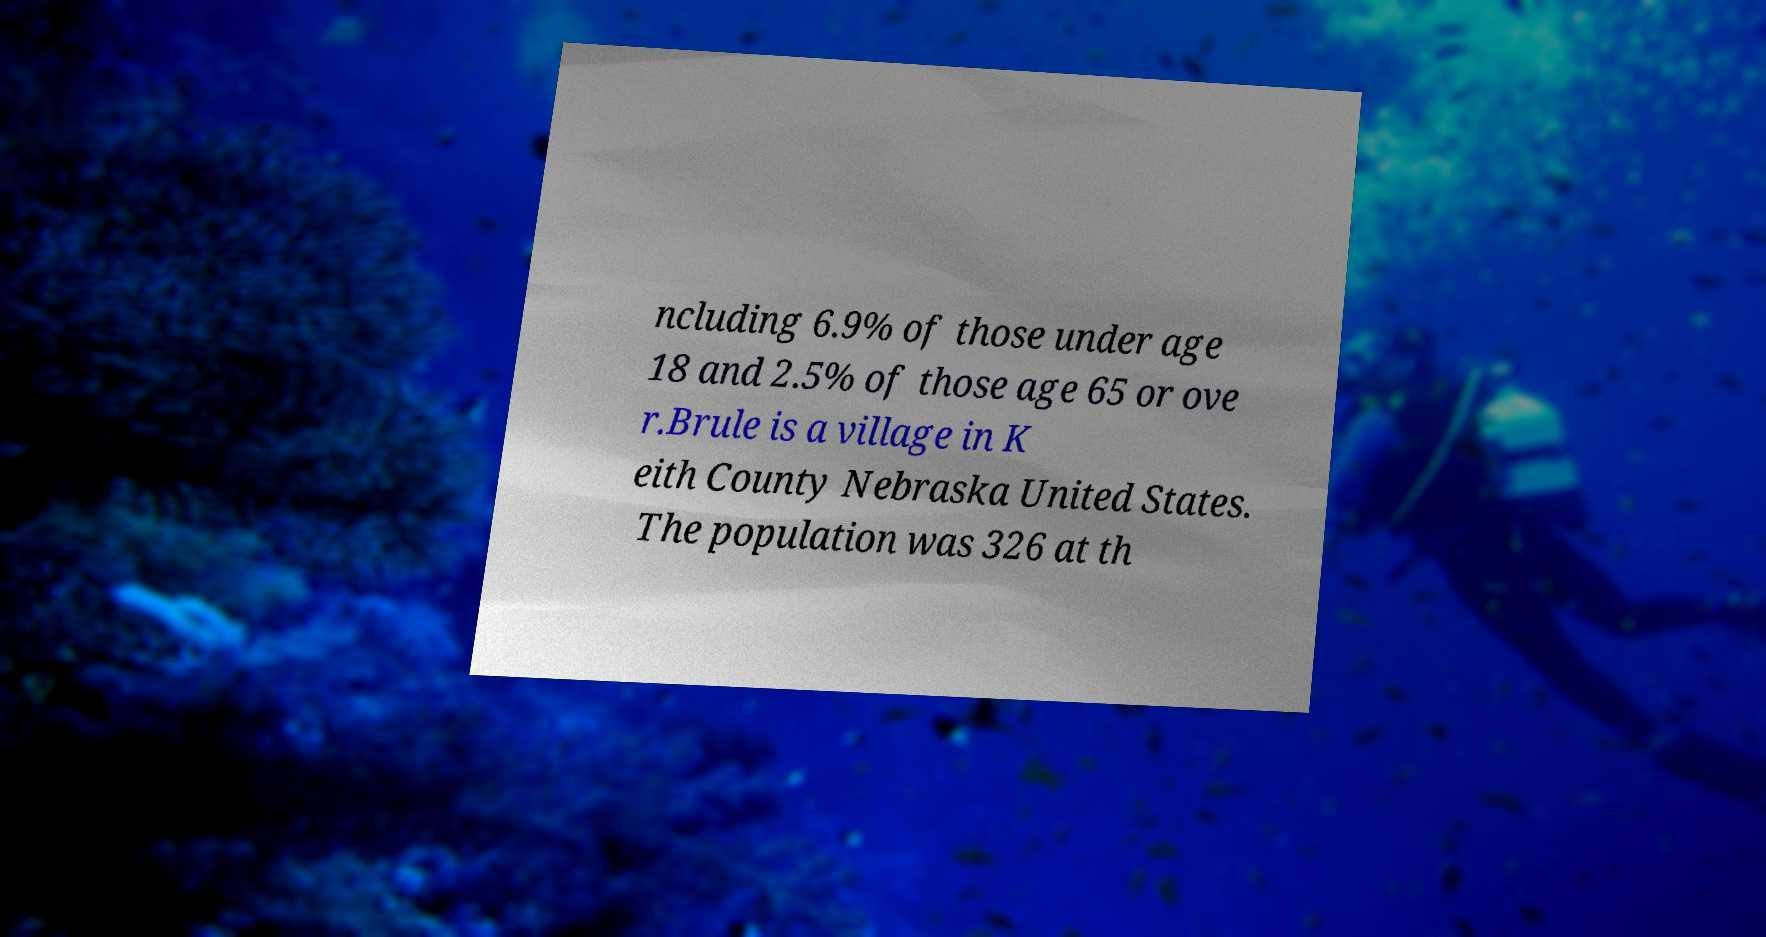Please read and relay the text visible in this image. What does it say? ncluding 6.9% of those under age 18 and 2.5% of those age 65 or ove r.Brule is a village in K eith County Nebraska United States. The population was 326 at th 